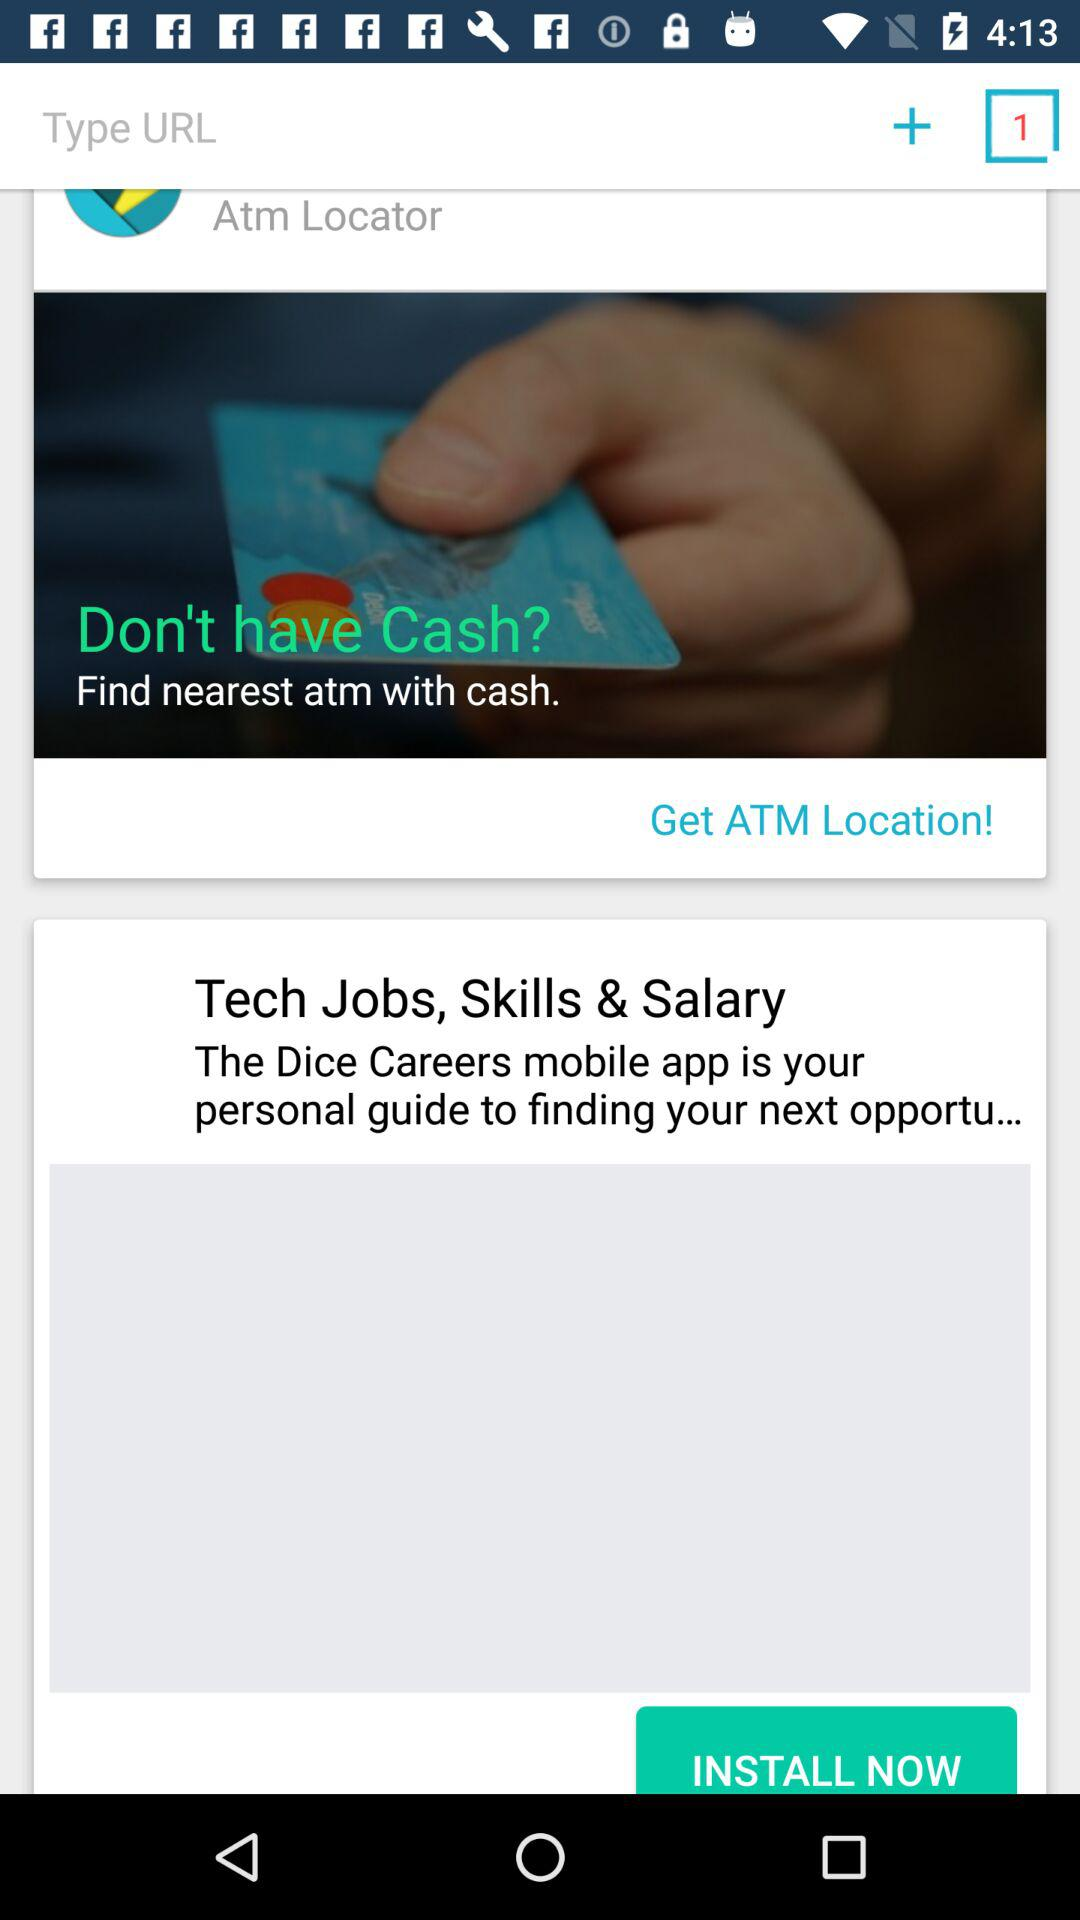What career mobile app is the personal guide? It is "Dice Careers". 